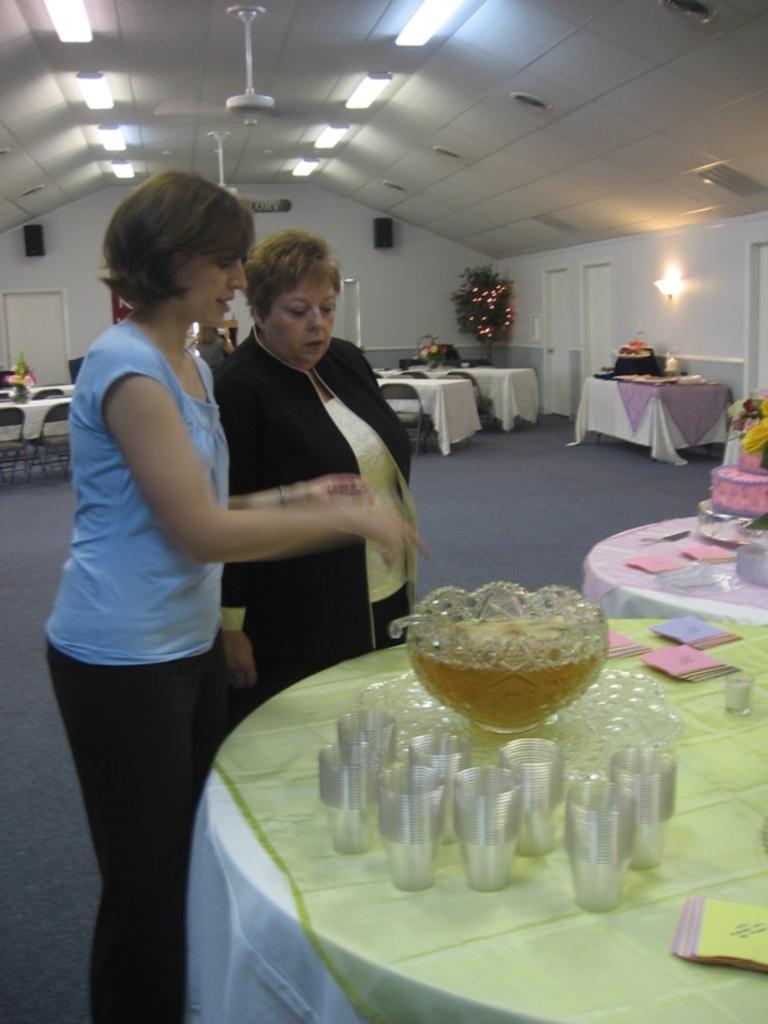In one or two sentences, can you explain what this image depicts? This picture is inside a hall. Two women are standing in front of a table. On the table there are glasses , bowl, papers. There are few other tables. On the ceiling there are lights and fan. There is a carpet on the floor. Few chairs are around the tables. 